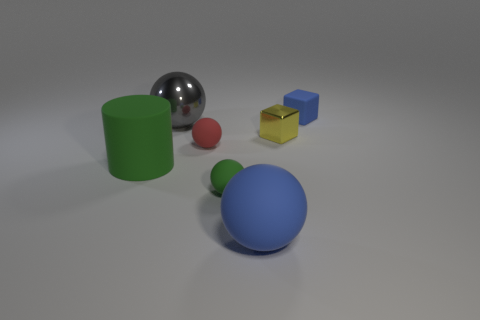Add 2 small spheres. How many objects exist? 9 Subtract all blocks. How many objects are left? 5 Add 5 tiny red things. How many tiny red things are left? 6 Add 2 tiny red matte things. How many tiny red matte things exist? 3 Subtract 0 yellow cylinders. How many objects are left? 7 Subtract all tiny blue things. Subtract all red rubber objects. How many objects are left? 5 